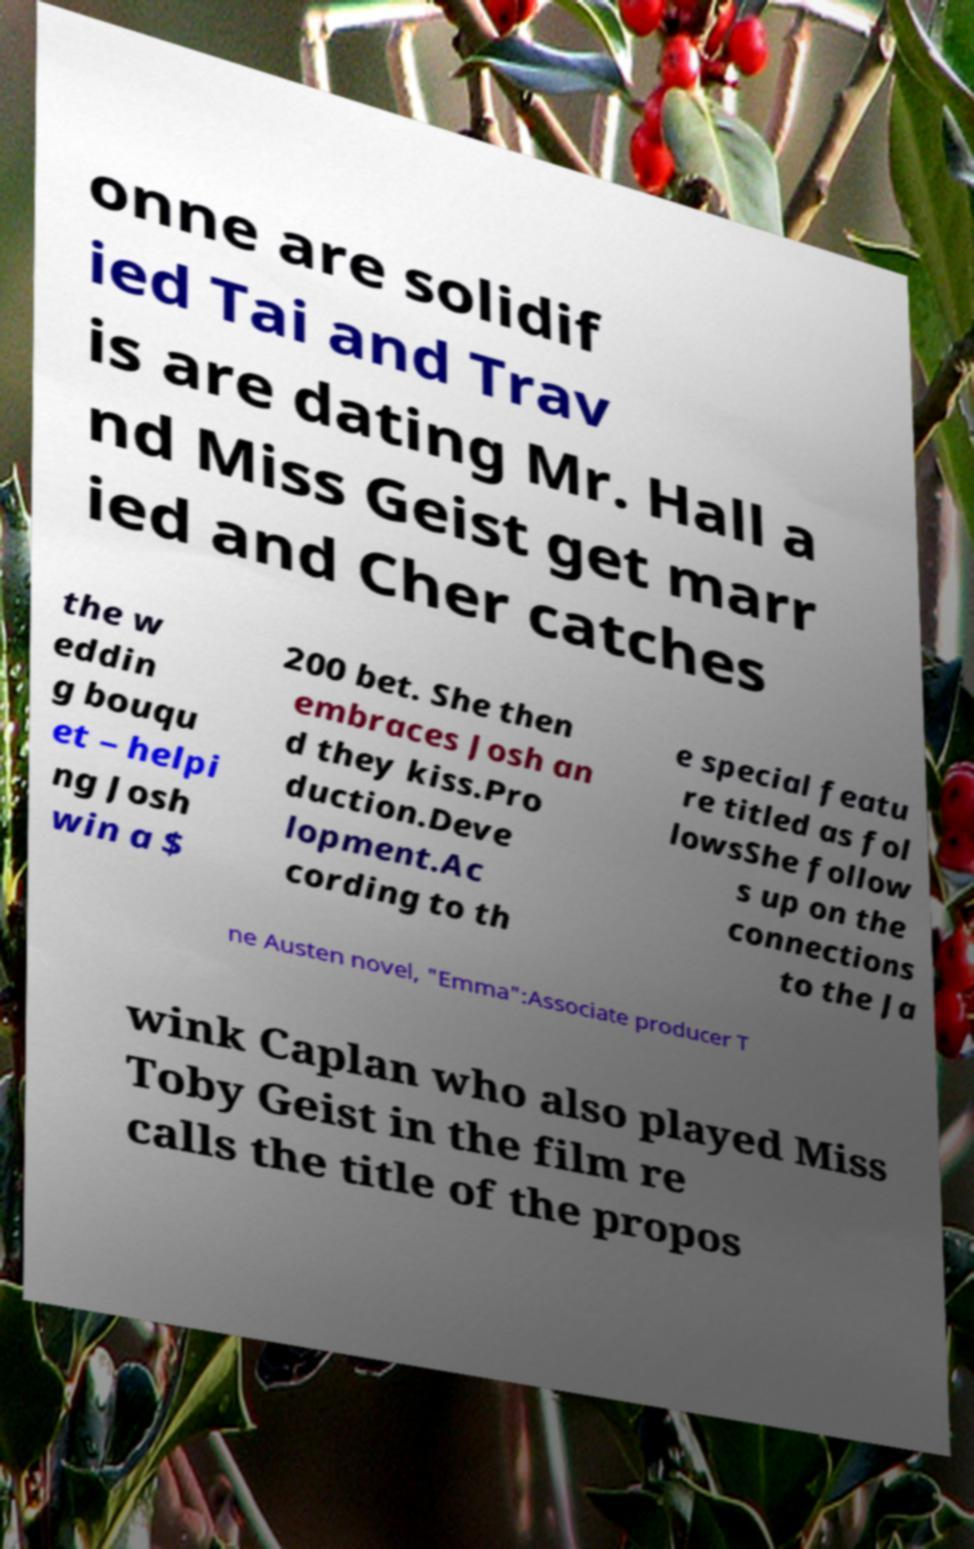For documentation purposes, I need the text within this image transcribed. Could you provide that? onne are solidif ied Tai and Trav is are dating Mr. Hall a nd Miss Geist get marr ied and Cher catches the w eddin g bouqu et – helpi ng Josh win a $ 200 bet. She then embraces Josh an d they kiss.Pro duction.Deve lopment.Ac cording to th e special featu re titled as fol lowsShe follow s up on the connections to the Ja ne Austen novel, "Emma":Associate producer T wink Caplan who also played Miss Toby Geist in the film re calls the title of the propos 